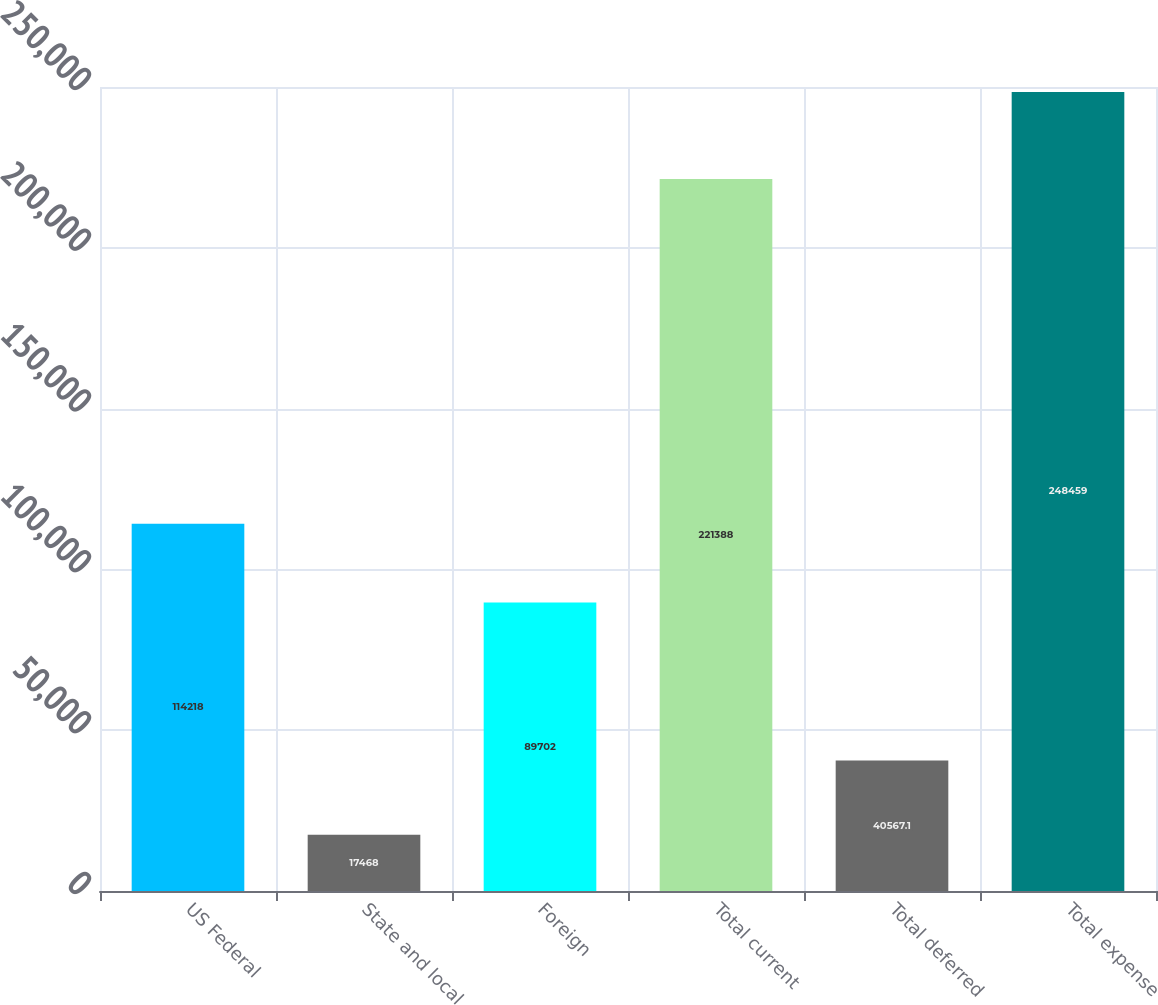<chart> <loc_0><loc_0><loc_500><loc_500><bar_chart><fcel>US Federal<fcel>State and local<fcel>Foreign<fcel>Total current<fcel>Total deferred<fcel>Total expense<nl><fcel>114218<fcel>17468<fcel>89702<fcel>221388<fcel>40567.1<fcel>248459<nl></chart> 